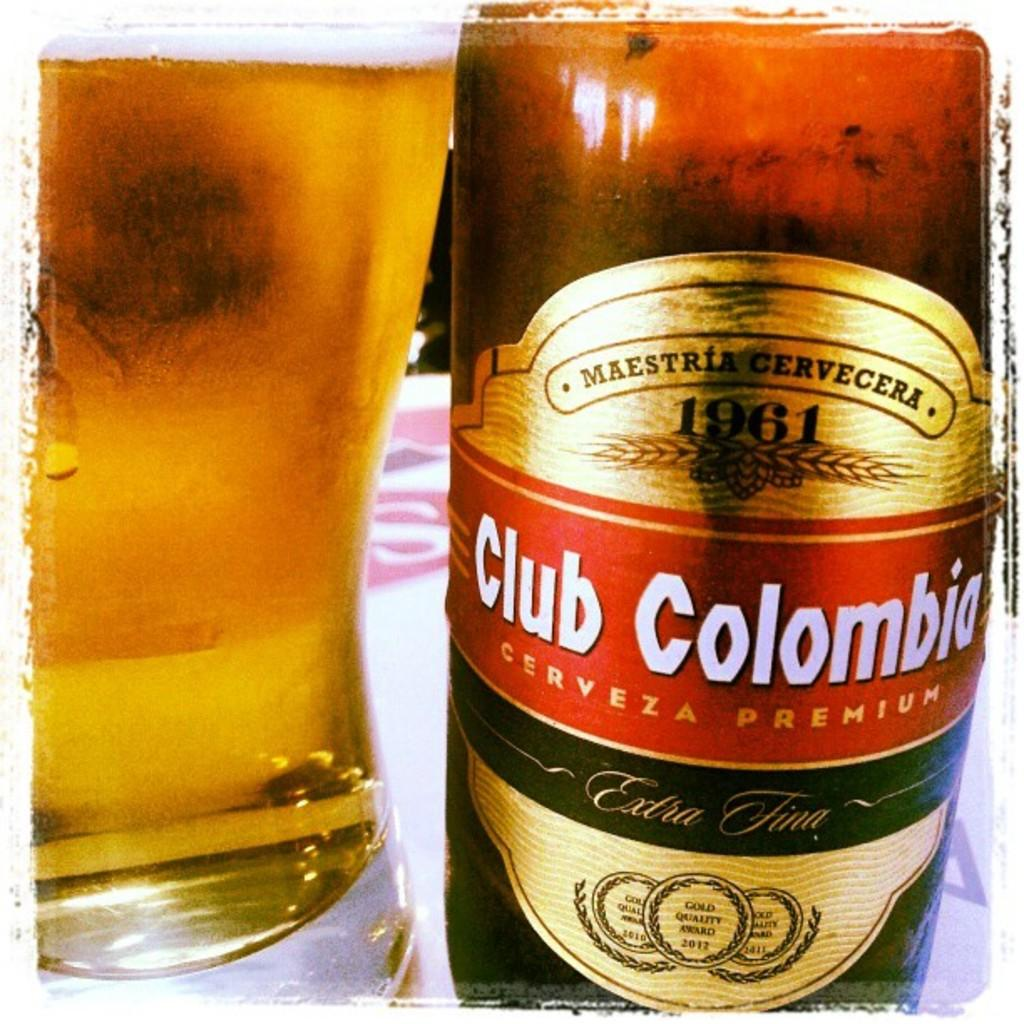Provide a one-sentence caption for the provided image. A glass full of beer is next to the beer bottle of Club Colombia. 